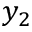<formula> <loc_0><loc_0><loc_500><loc_500>y _ { 2 }</formula> 